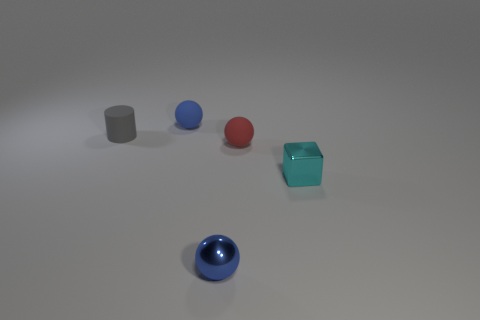Is the shape of the blue metallic thing the same as the blue rubber thing?
Keep it short and to the point. Yes. There is a metallic object that is to the left of the red matte thing; does it have the same shape as the small blue matte thing?
Your answer should be very brief. Yes. The thing that is the same color as the shiny ball is what shape?
Give a very brief answer. Sphere. Is there a blue sphere that has the same material as the cyan block?
Your answer should be compact. Yes. What size is the cylinder?
Offer a very short reply. Small. How many cyan things are small rubber objects or tiny cubes?
Give a very brief answer. 1. How many small red matte things are the same shape as the small cyan object?
Your answer should be compact. 0. How many cylinders have the same size as the red rubber ball?
Give a very brief answer. 1. What material is the small red object that is the same shape as the small blue rubber object?
Your answer should be compact. Rubber. What color is the object in front of the tiny cyan metallic cube?
Ensure brevity in your answer.  Blue. 